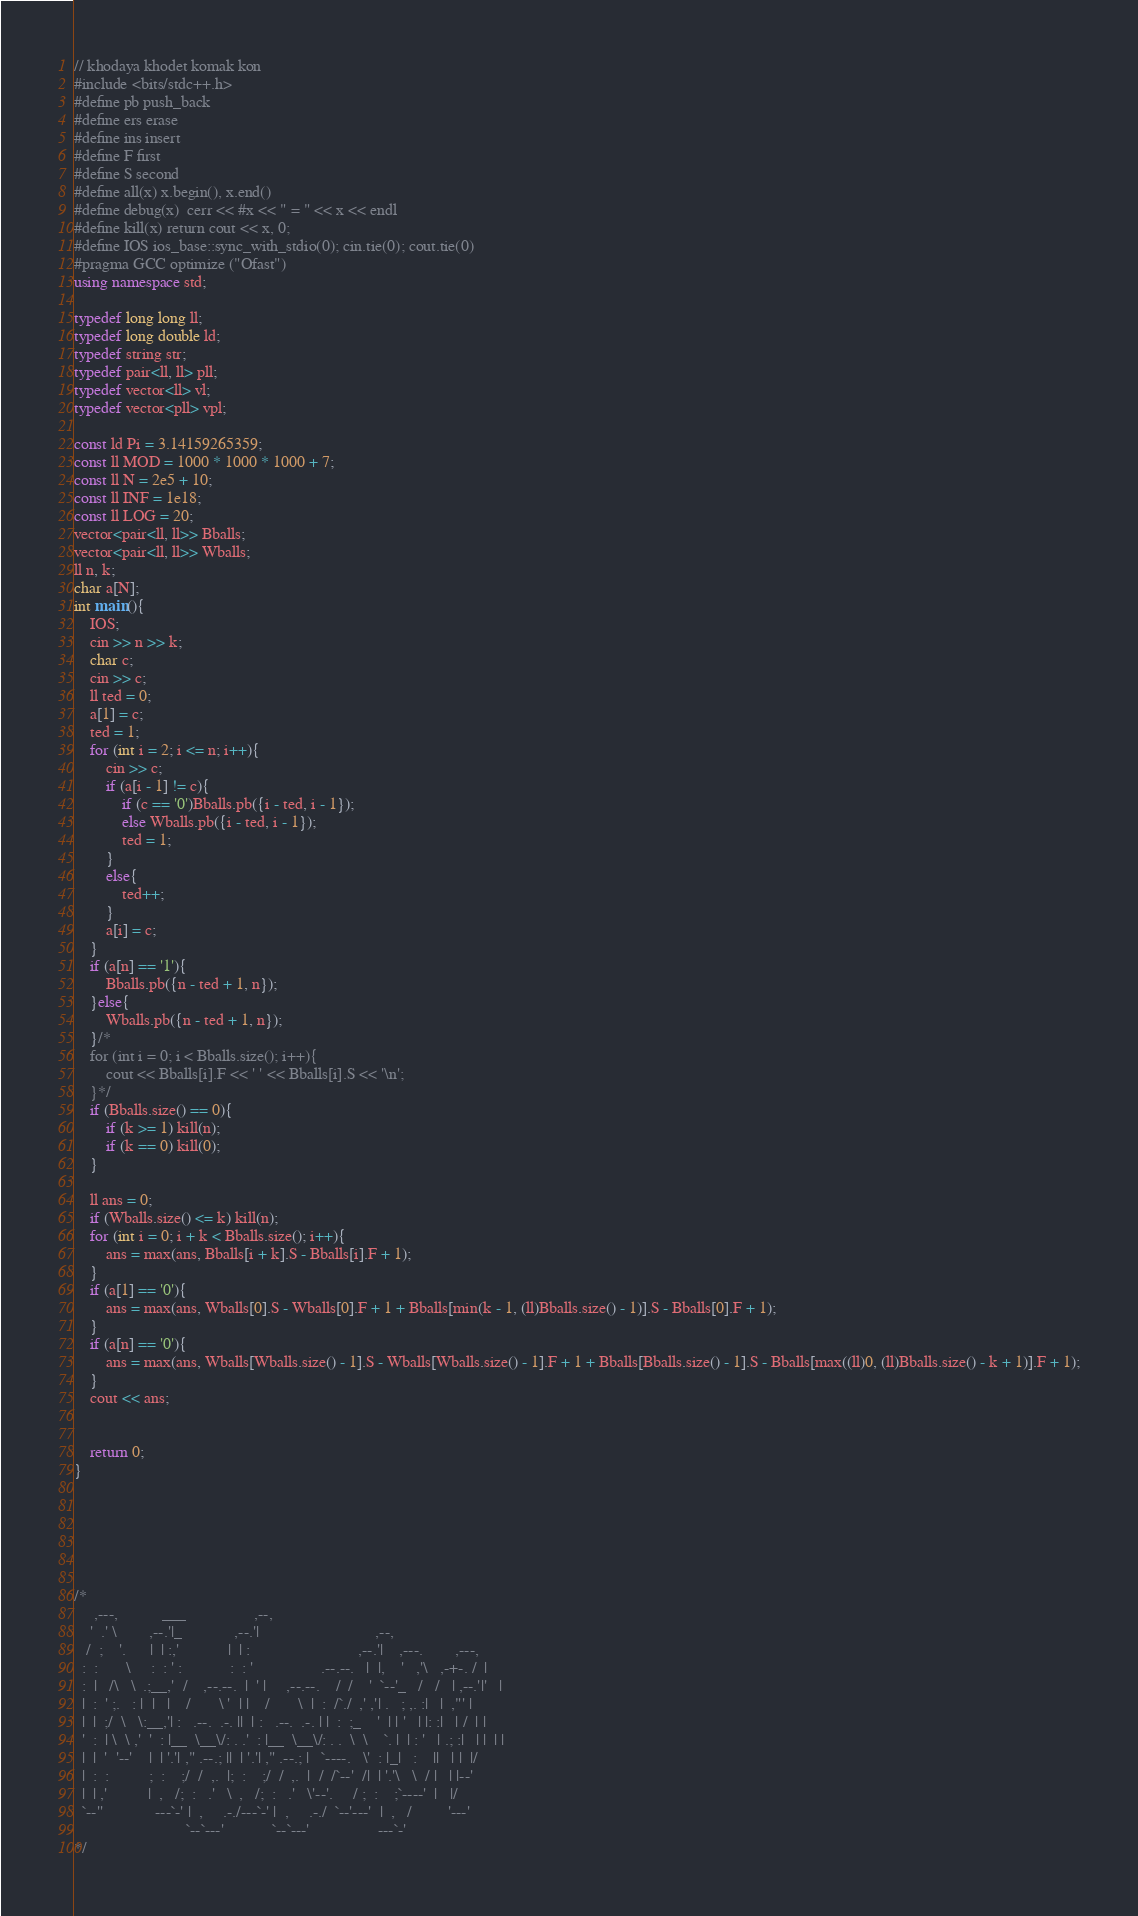Convert code to text. <code><loc_0><loc_0><loc_500><loc_500><_C++_>// khodaya khodet komak kon
#include <bits/stdc++.h>
#define pb push_back
#define ers erase
#define ins insert
#define F first
#define S second
#define all(x) x.begin(), x.end()
#define debug(x)  cerr << #x << " = " << x << endl
#define kill(x) return cout << x, 0;
#define IOS ios_base::sync_with_stdio(0); cin.tie(0); cout.tie(0)
#pragma GCC optimize ("Ofast")
using namespace std;

typedef long long ll;
typedef long double ld;
typedef string str;
typedef pair<ll, ll> pll;
typedef vector<ll> vl;
typedef vector<pll> vpl;

const ld Pi = 3.14159265359;
const ll MOD = 1000 * 1000 * 1000 + 7;
const ll N = 2e5 + 10;
const ll INF = 1e18;
const ll LOG = 20;
vector<pair<ll, ll>> Bballs;
vector<pair<ll, ll>> Wballs;
ll n, k;
char a[N];
int main(){
	IOS;
	cin >> n >> k;
	char c;
	cin >> c;
	ll ted = 0;
	a[1] = c;
	ted = 1;
	for (int i = 2; i <= n; i++){
		cin >> c;
		if (a[i - 1] != c){
			if (c == '0')Bballs.pb({i - ted, i - 1});
			else Wballs.pb({i - ted, i - 1});
			ted = 1;
		}
		else{
			ted++;
		}
		a[i] = c;
	}
	if (a[n] == '1'){
		Bballs.pb({n - ted + 1, n});
	}else{
		Wballs.pb({n - ted + 1, n});
	}/*
	for (int i = 0; i < Bballs.size(); i++){
		cout << Bballs[i].F << ' ' << Bballs[i].S << '\n';
	}*/
	if (Bballs.size() == 0){
		if (k >= 1) kill(n);
		if (k == 0) kill(0);
	}
	
	ll ans = 0;
	if (Wballs.size() <= k) kill(n);
 	for (int i = 0; i + k < Bballs.size(); i++){
		ans = max(ans, Bballs[i + k].S - Bballs[i].F + 1);
	}
	if (a[1] == '0'){
		ans = max(ans, Wballs[0].S - Wballs[0].F + 1 + Bballs[min(k - 1, (ll)Bballs.size() - 1)].S - Bballs[0].F + 1);
	}
	if (a[n] == '0'){
		ans = max(ans, Wballs[Wballs.size() - 1].S - Wballs[Wballs.size() - 1].F + 1 + Bballs[Bballs.size() - 1].S - Bballs[max((ll)0, (ll)Bballs.size() - k + 1)].F + 1);
	}
	cout << ans;
	
	
	return 0;
}






/*
     ,---,           ___                 ,--,
    '  .' \        ,--.'|_             ,--.'|                             ,--,
   /  ;    '.      |  | :,'            |  | :                           ,--.'|    ,---.        ,---,
  :  :       \     :  : ' :            :  : '                 .--.--.   |  |,    '   ,'\   ,-+-. /  |
  :  |   /\   \  .;__,'  /    ,--.--.  |  ' |     ,--.--.    /  /    '  `--'_   /   /   | ,--.'|'   |
  |  :  ' ;.   : |  |   |    /       \ '  | |    /       \  |  :  /`./  ,' ,'| .   ; ,. :|   |  ,"' |
  |  |  ;/  \   \:__,'| :   .--.  .-. ||  | :   .--.  .-. | |  :  ;_    '  | | '   | |: :|   | /  | |
  '  :  | \  \ ,'  '  : |__  \__\/: . .'  : |__  \__\/: . .  \  \    `. |  | : '   | .; :|   | |  | |
  |  |  '  '--'    |  | '.'| ," .--.; ||  | '.'| ," .--.; |   `----.   \'  : |_|   :    ||   | |  |/
  |  :  :          ;  :    ;/  /  ,.  |;  :    ;/  /  ,.  |  /  /`--'  /|  | '.'\   \  / |   | |--'
  |  | ,'          |  ,   /;  :   .'   \  ,   /;  :   .'   \'--'.     / ;  :    ;`----'  |   |/
  `--''             ---`-' |  ,     .-./---`-' |  ,     .-./  `--'---'  |  ,   /         '---'
                            `--`---'            `--`---'                 ---`-'
*/


</code> 